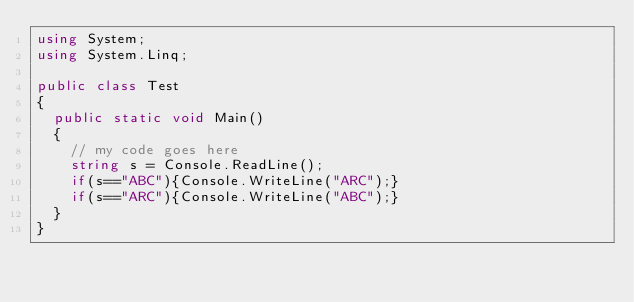Convert code to text. <code><loc_0><loc_0><loc_500><loc_500><_C#_>using System;
using System.Linq;

public class Test
{
	public static void Main()
	{
		// my code goes here
		string s = Console.ReadLine();
		if(s=="ABC"){Console.WriteLine("ARC");}
		if(s=="ARC"){Console.WriteLine("ABC");}
	}
}</code> 